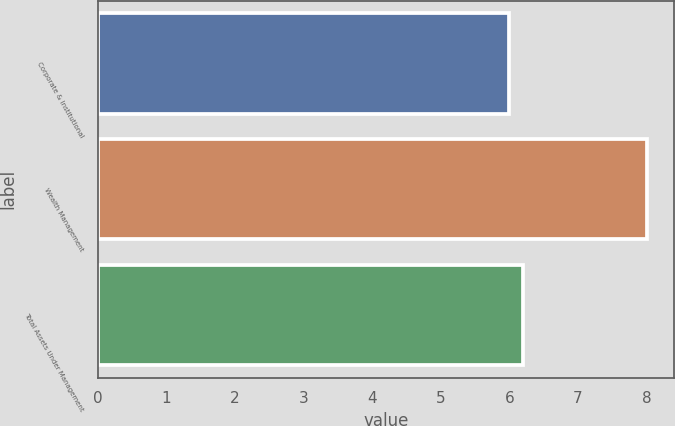<chart> <loc_0><loc_0><loc_500><loc_500><bar_chart><fcel>Corporate & Institutional<fcel>Wealth Management<fcel>Total Assets Under Management<nl><fcel>6<fcel>8<fcel>6.2<nl></chart> 